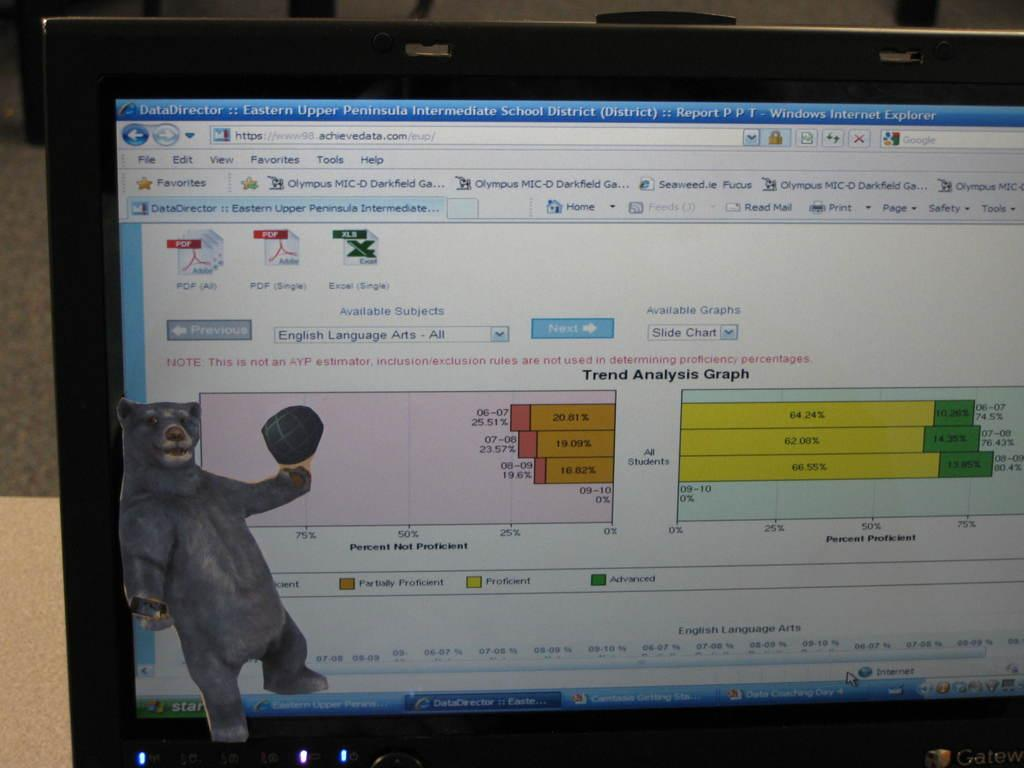<image>
Offer a succinct explanation of the picture presented. Monitor showing an internet explorer page on "achievedata.com". 